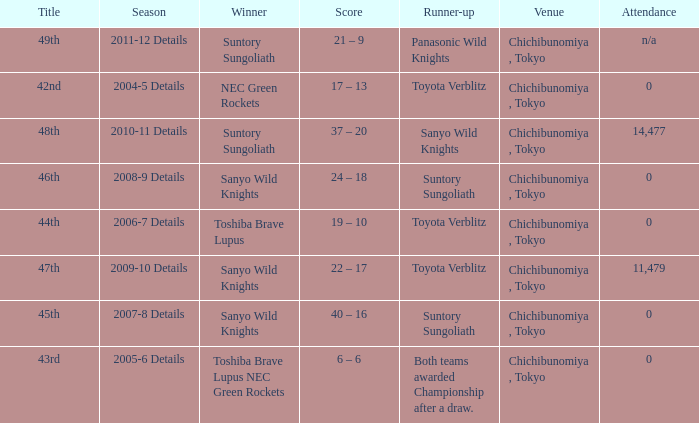Parse the full table. {'header': ['Title', 'Season', 'Winner', 'Score', 'Runner-up', 'Venue', 'Attendance'], 'rows': [['49th', '2011-12 Details', 'Suntory Sungoliath', '21 – 9', 'Panasonic Wild Knights', 'Chichibunomiya , Tokyo', 'n/a'], ['42nd', '2004-5 Details', 'NEC Green Rockets', '17 – 13', 'Toyota Verblitz', 'Chichibunomiya , Tokyo', '0'], ['48th', '2010-11 Details', 'Suntory Sungoliath', '37 – 20', 'Sanyo Wild Knights', 'Chichibunomiya , Tokyo', '14,477'], ['46th', '2008-9 Details', 'Sanyo Wild Knights', '24 – 18', 'Suntory Sungoliath', 'Chichibunomiya , Tokyo', '0'], ['44th', '2006-7 Details', 'Toshiba Brave Lupus', '19 – 10', 'Toyota Verblitz', 'Chichibunomiya , Tokyo', '0'], ['47th', '2009-10 Details', 'Sanyo Wild Knights', '22 – 17', 'Toyota Verblitz', 'Chichibunomiya , Tokyo', '11,479'], ['45th', '2007-8 Details', 'Sanyo Wild Knights', '40 – 16', 'Suntory Sungoliath', 'Chichibunomiya , Tokyo', '0'], ['43rd', '2005-6 Details', 'Toshiba Brave Lupus NEC Green Rockets', '6 – 6', 'Both teams awarded Championship after a draw.', 'Chichibunomiya , Tokyo', '0']]} What is the Score when the winner was suntory sungoliath, and the number attendance was n/a? 21 – 9. 